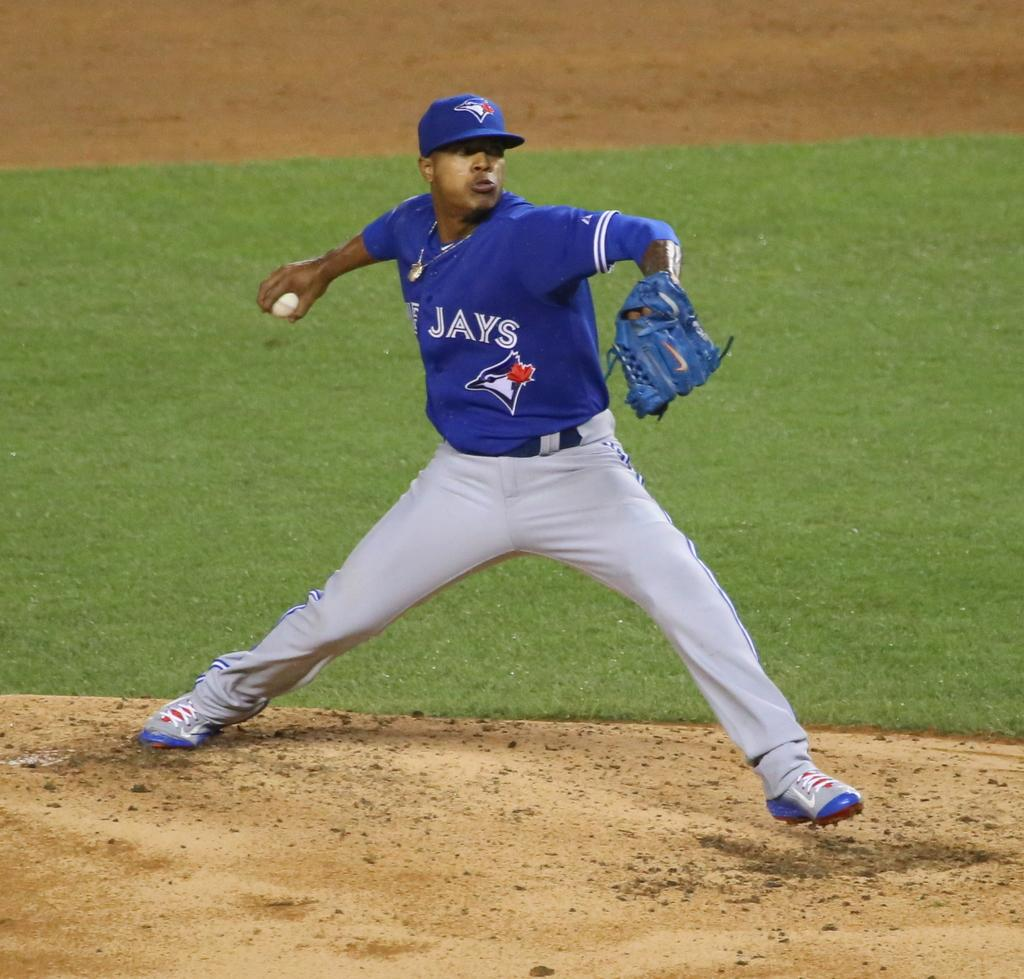<image>
Present a compact description of the photo's key features. A baseball player is throwing a ball with Jays on his jersey. 